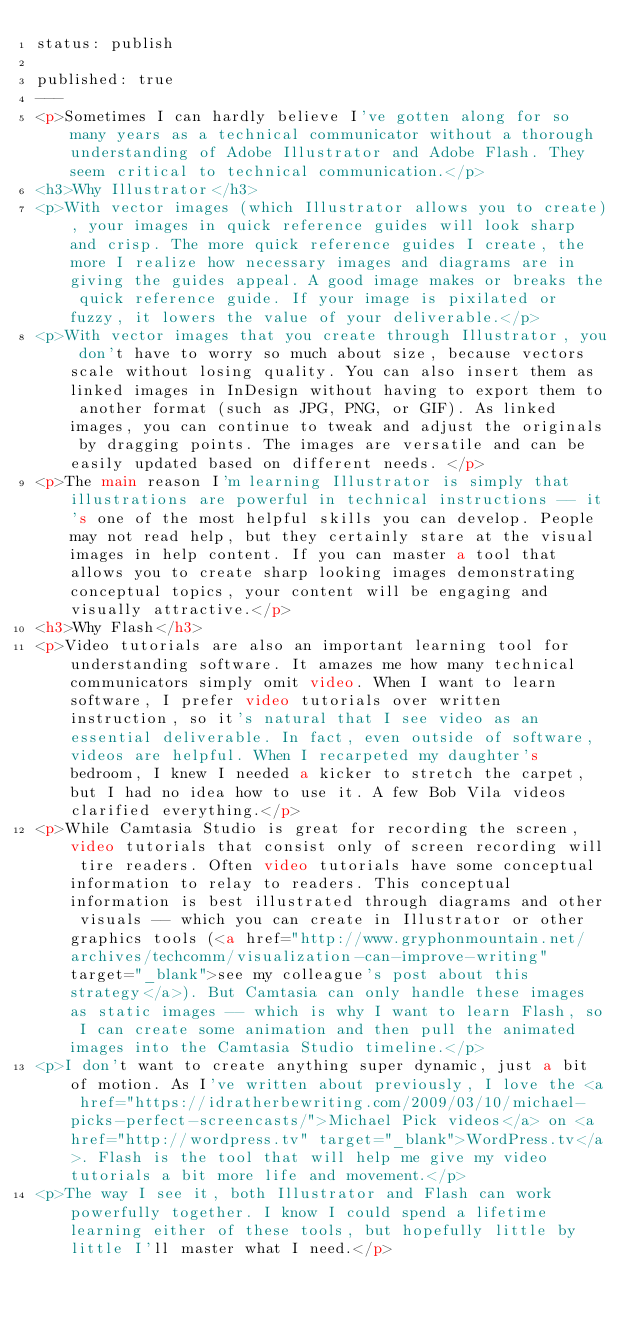<code> <loc_0><loc_0><loc_500><loc_500><_HTML_>status: publish

published: true
---
<p>Sometimes I can hardly believe I've gotten along for so many years as a technical communicator without a thorough understanding of Adobe Illustrator and Adobe Flash. They seem critical to technical communication.</p>
<h3>Why Illustrator</h3>
<p>With vector images (which Illustrator allows you to create), your images in quick reference guides will look sharp and crisp. The more quick reference guides I create, the more I realize how necessary images and diagrams are in giving the guides appeal. A good image makes or breaks the quick reference guide. If your image is pixilated or fuzzy, it lowers the value of your deliverable.</p>
<p>With vector images that you create through Illustrator, you don't have to worry so much about size, because vectors scale without losing quality. You can also insert them as linked images in InDesign without having to export them to another format (such as JPG, PNG, or GIF). As linked images, you can continue to tweak and adjust the originals by dragging points. The images are versatile and can be easily updated based on different needs. </p>
<p>The main reason I'm learning Illustrator is simply that illustrations are powerful in technical instructions -- it's one of the most helpful skills you can develop. People may not read help, but they certainly stare at the visual images in help content. If you can master a tool that allows you to create sharp looking images demonstrating conceptual topics, your content will be engaging and visually attractive.</p>
<h3>Why Flash</h3>
<p>Video tutorials are also an important learning tool for understanding software. It amazes me how many technical communicators simply omit video. When I want to learn software, I prefer video tutorials over written instruction, so it's natural that I see video as an essential deliverable. In fact, even outside of software, videos are helpful. When I recarpeted my daughter's bedroom, I knew I needed a kicker to stretch the carpet, but I had no idea how to use it. A few Bob Vila videos clarified everything.</p>
<p>While Camtasia Studio is great for recording the screen, video tutorials that consist only of screen recording will tire readers. Often video tutorials have some conceptual information to relay to readers. This conceptual information is best illustrated through diagrams and other visuals -- which you can create in Illustrator or other graphics tools (<a href="http://www.gryphonmountain.net/archives/techcomm/visualization-can-improve-writing" target="_blank">see my colleague's post about this strategy</a>). But Camtasia can only handle these images as static images -- which is why I want to learn Flash, so I can create some animation and then pull the animated images into the Camtasia Studio timeline.</p>
<p>I don't want to create anything super dynamic, just a bit of motion. As I've written about previously, I love the <a href="https://idratherbewriting.com/2009/03/10/michael-picks-perfect-screencasts/">Michael Pick videos</a> on <a href="http://wordpress.tv" target="_blank">WordPress.tv</a>. Flash is the tool that will help me give my video tutorials a bit more life and movement.</p>
<p>The way I see it, both Illustrator and Flash can work powerfully together. I know I could spend a lifetime learning either of these tools, but hopefully little by little I'll master what I need.</p>
</code> 